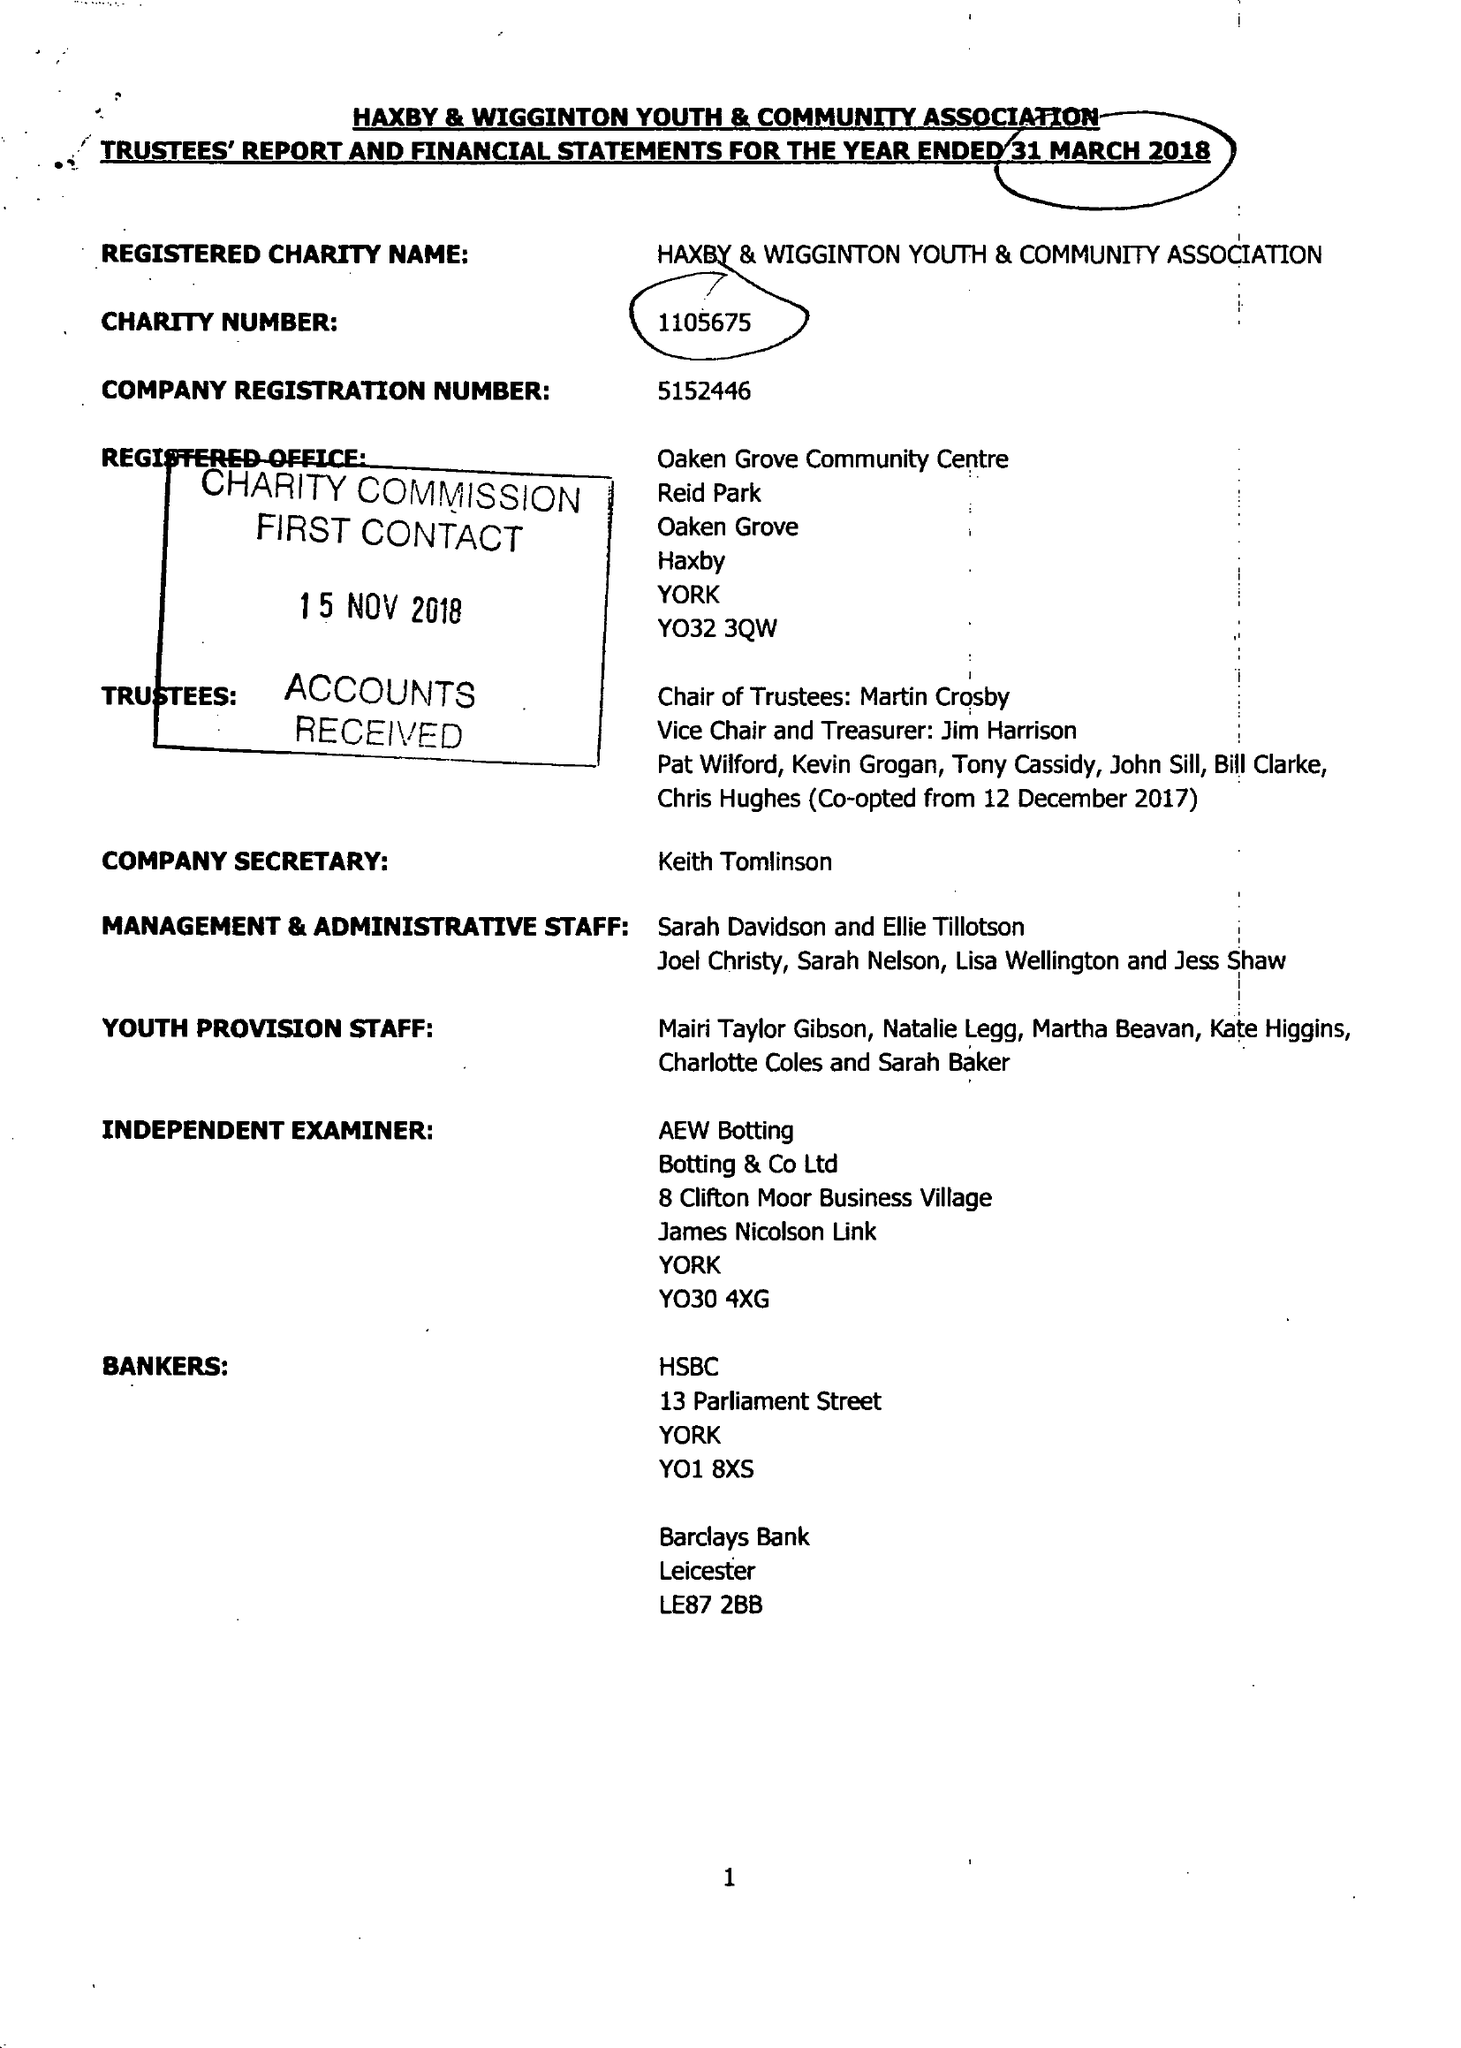What is the value for the income_annually_in_british_pounds?
Answer the question using a single word or phrase. 70294.00 